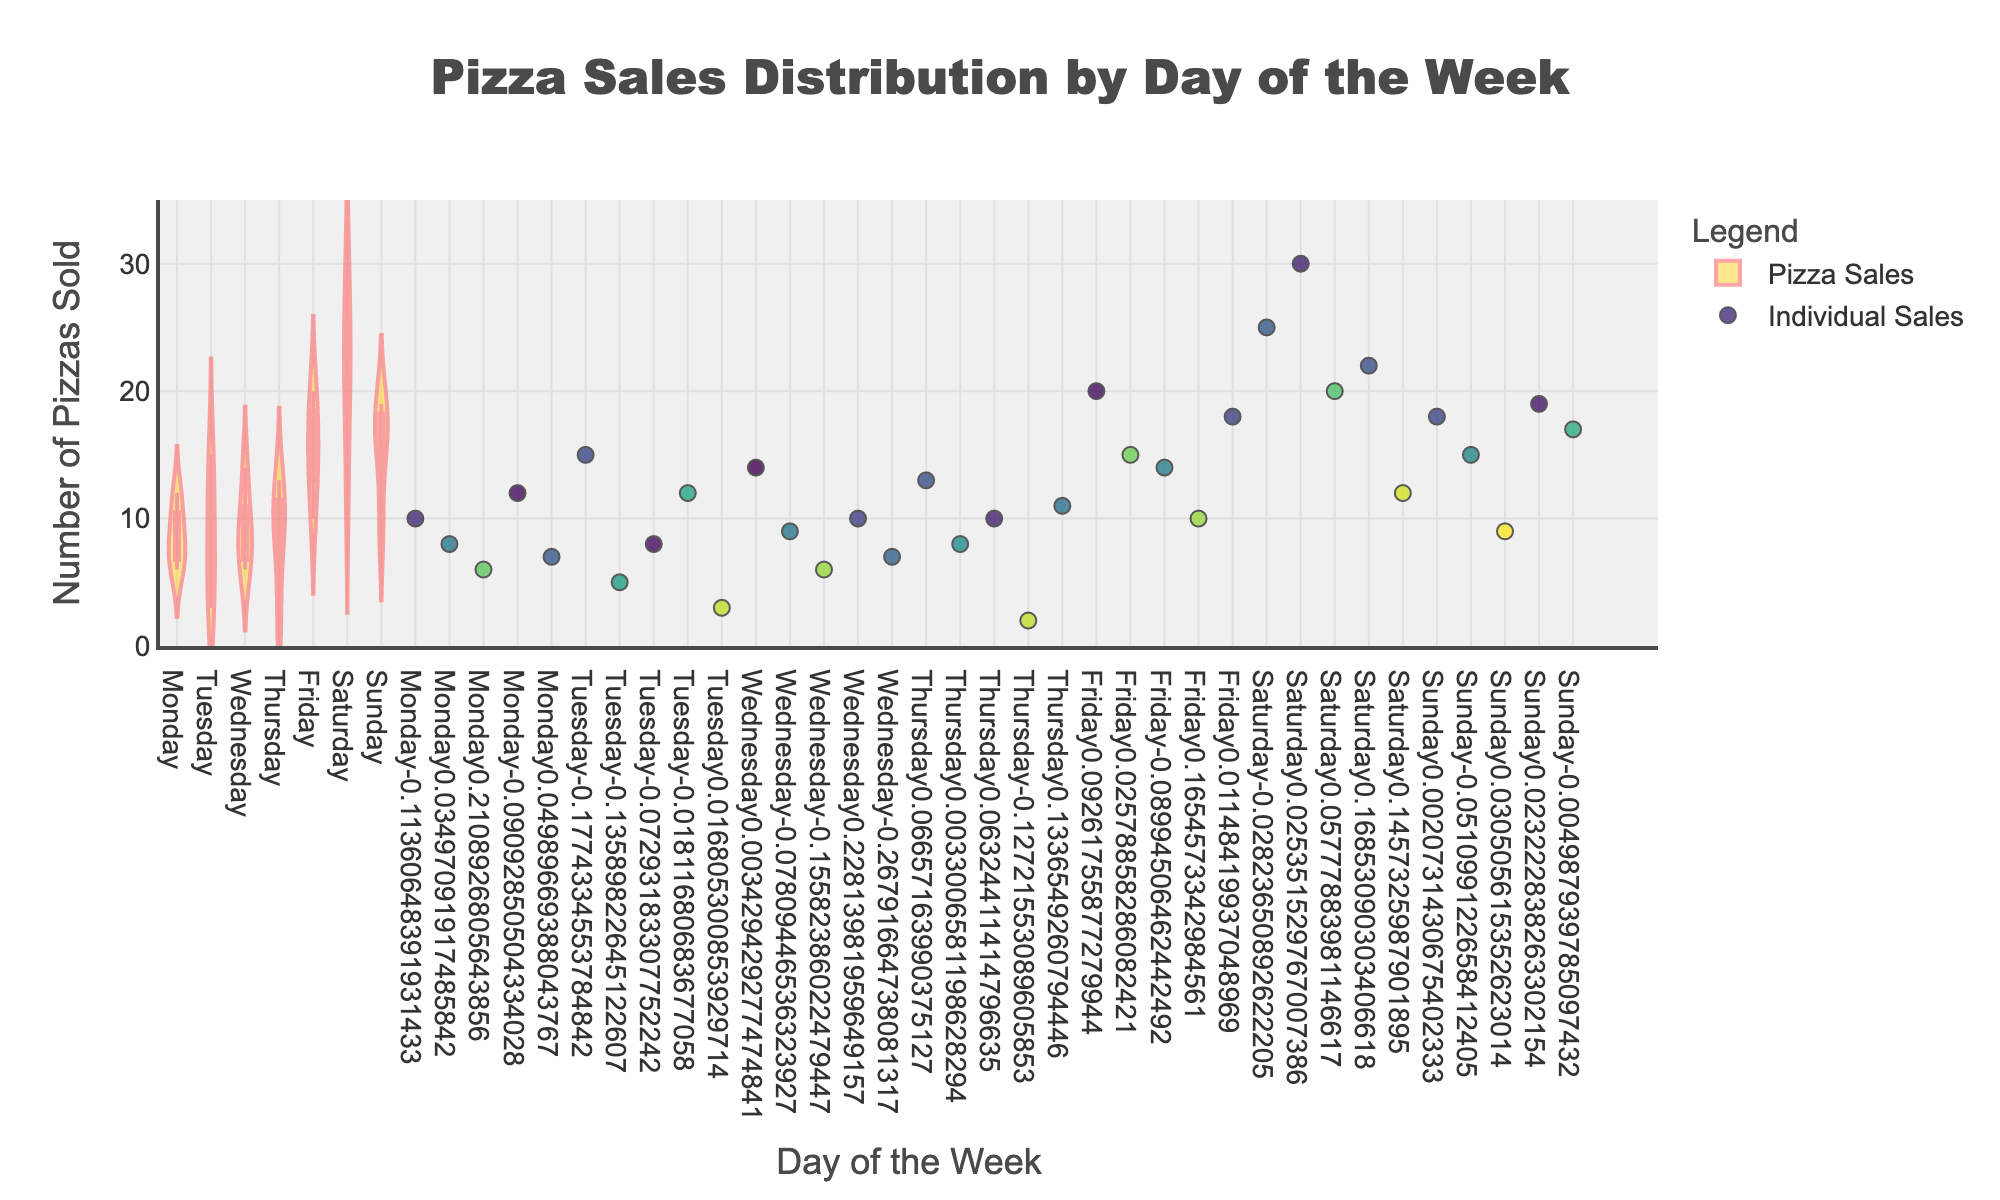What is the title of the figure? The title is displayed at the top center of the plot. It states what the chart represents regarding the pizza sales distribution.
Answer: "Pizza Sales Distribution by Day of the Week" How many individual data points are represented in the figure? Each jittered point on the plot represents an individual data point, which can be counted visually. In this case, there are 35 total data points.
Answer: 35 What day of the week has the highest median pizza sales? To find the highest median pizza sales, refer to the horizontal line inside the violin plot for each day. The day with the highest median sales value will have the highest position of this line.
Answer: Saturday Which day shows the most variability in pizza sales? Variability can be observed by looking at the width and spread of the violin plot for each day. The day with the widest and most spread-out violin plot shows the most variability.
Answer: Saturday Are there more pizzas sold on weekdays or weekends on average? First, sum the total pizzas sold on weekdays (Monday to Friday) and weekends (Saturday and Sunday). Then, divide each sum by the number of days in each category. Compare the two averages.
Answer: Weekends What is the relation between customer age and the number of pizzas sold? By looking at the color intensity of the jittered points, which is mapped to customer age, and comparing it with the number of pizzas sold on the y-axis, you can infer any trend or pattern.
Answer: Older customers tend to buy fewer pizzas on average Which day shows the smallest interquartile range (IQR) for pizza sales? The IQR is represented by the box inside each violin plot. The day with the smallest box has the smallest IQR.
Answer: Tuesday On which day do students buy the most pizzas? Hover over the jittered points to see customer occupations, and identify the points corresponding to students. Sum the pizzas sold by students for each day and compare.
Answer: Saturday How does the pizza consumption trend vary between gender? Evaluate the color information from jittered points to determine the gender (seen on hovering) and then observe if there's any noticeable variation in the amount of pizzas sold.
Answer: No significant gender difference What is the mean number of pizzas sold on Fridays? Calculate the mean by summing the number of pizzas sold on Fridays and then dividing by the number of data points for that day. (20 + 15 + 14 + 10 + 18) / 5 = 77 / 5
Answer: 15.4 